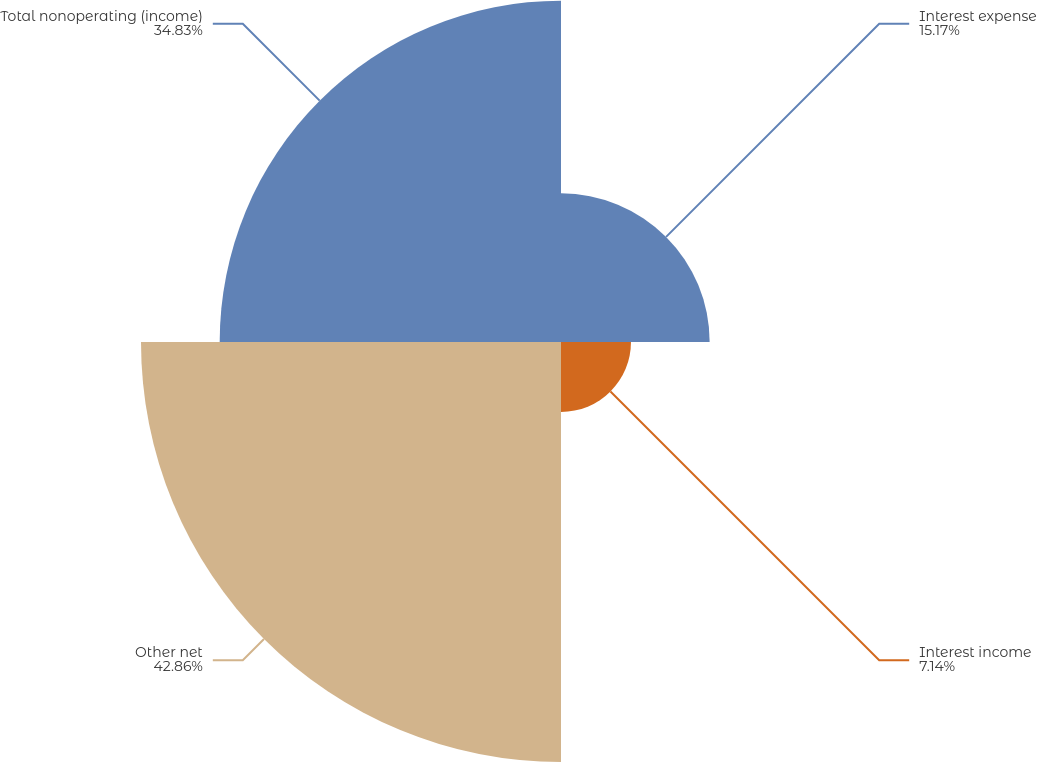<chart> <loc_0><loc_0><loc_500><loc_500><pie_chart><fcel>Interest expense<fcel>Interest income<fcel>Other net<fcel>Total nonoperating (income)<nl><fcel>15.17%<fcel>7.14%<fcel>42.86%<fcel>34.83%<nl></chart> 